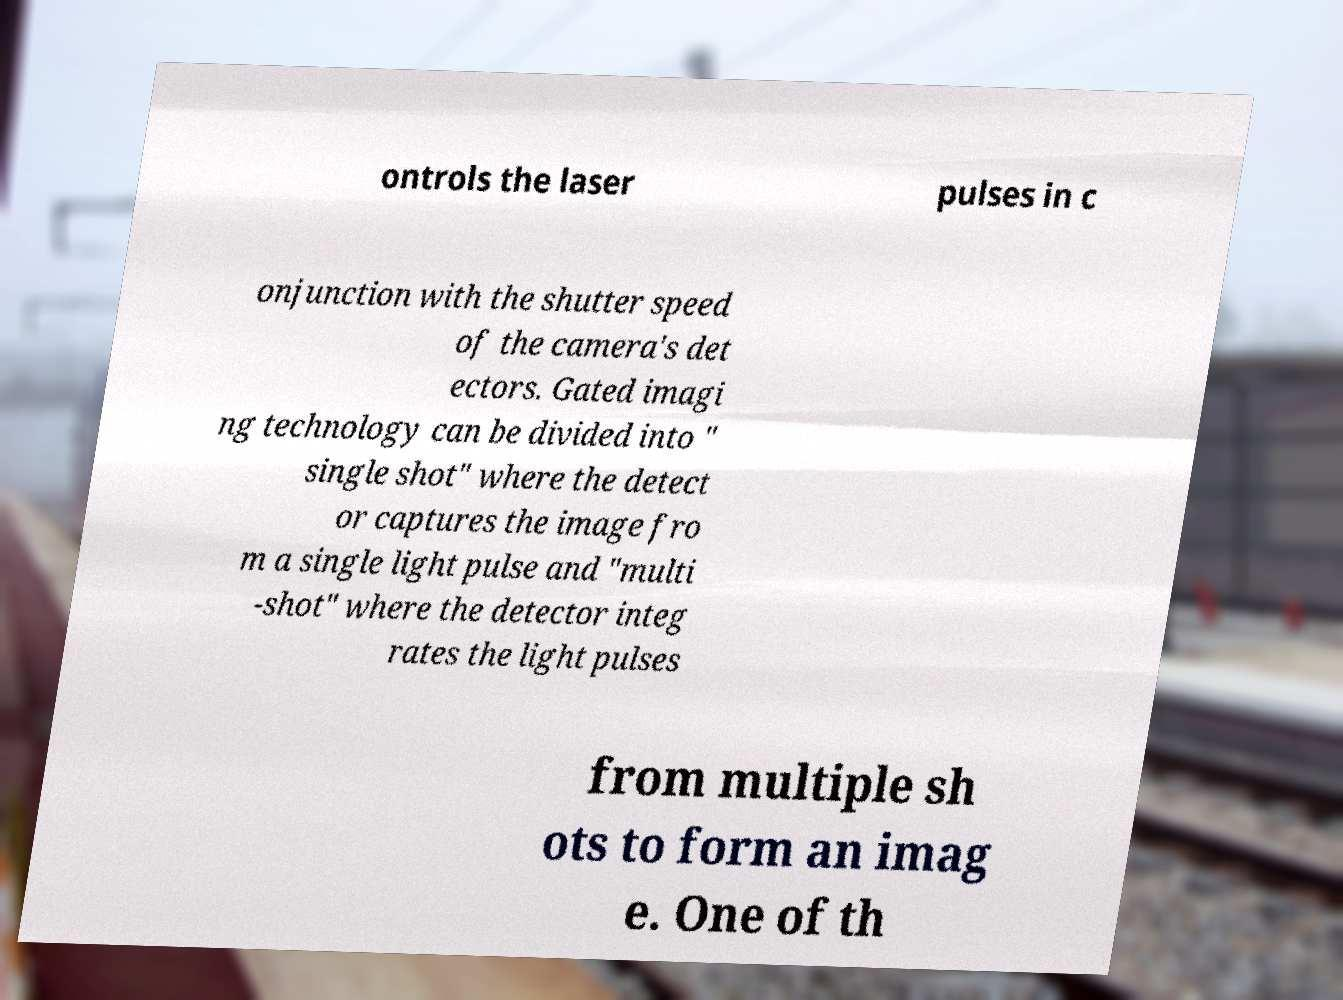Please read and relay the text visible in this image. What does it say? ontrols the laser pulses in c onjunction with the shutter speed of the camera's det ectors. Gated imagi ng technology can be divided into " single shot" where the detect or captures the image fro m a single light pulse and "multi -shot" where the detector integ rates the light pulses from multiple sh ots to form an imag e. One of th 